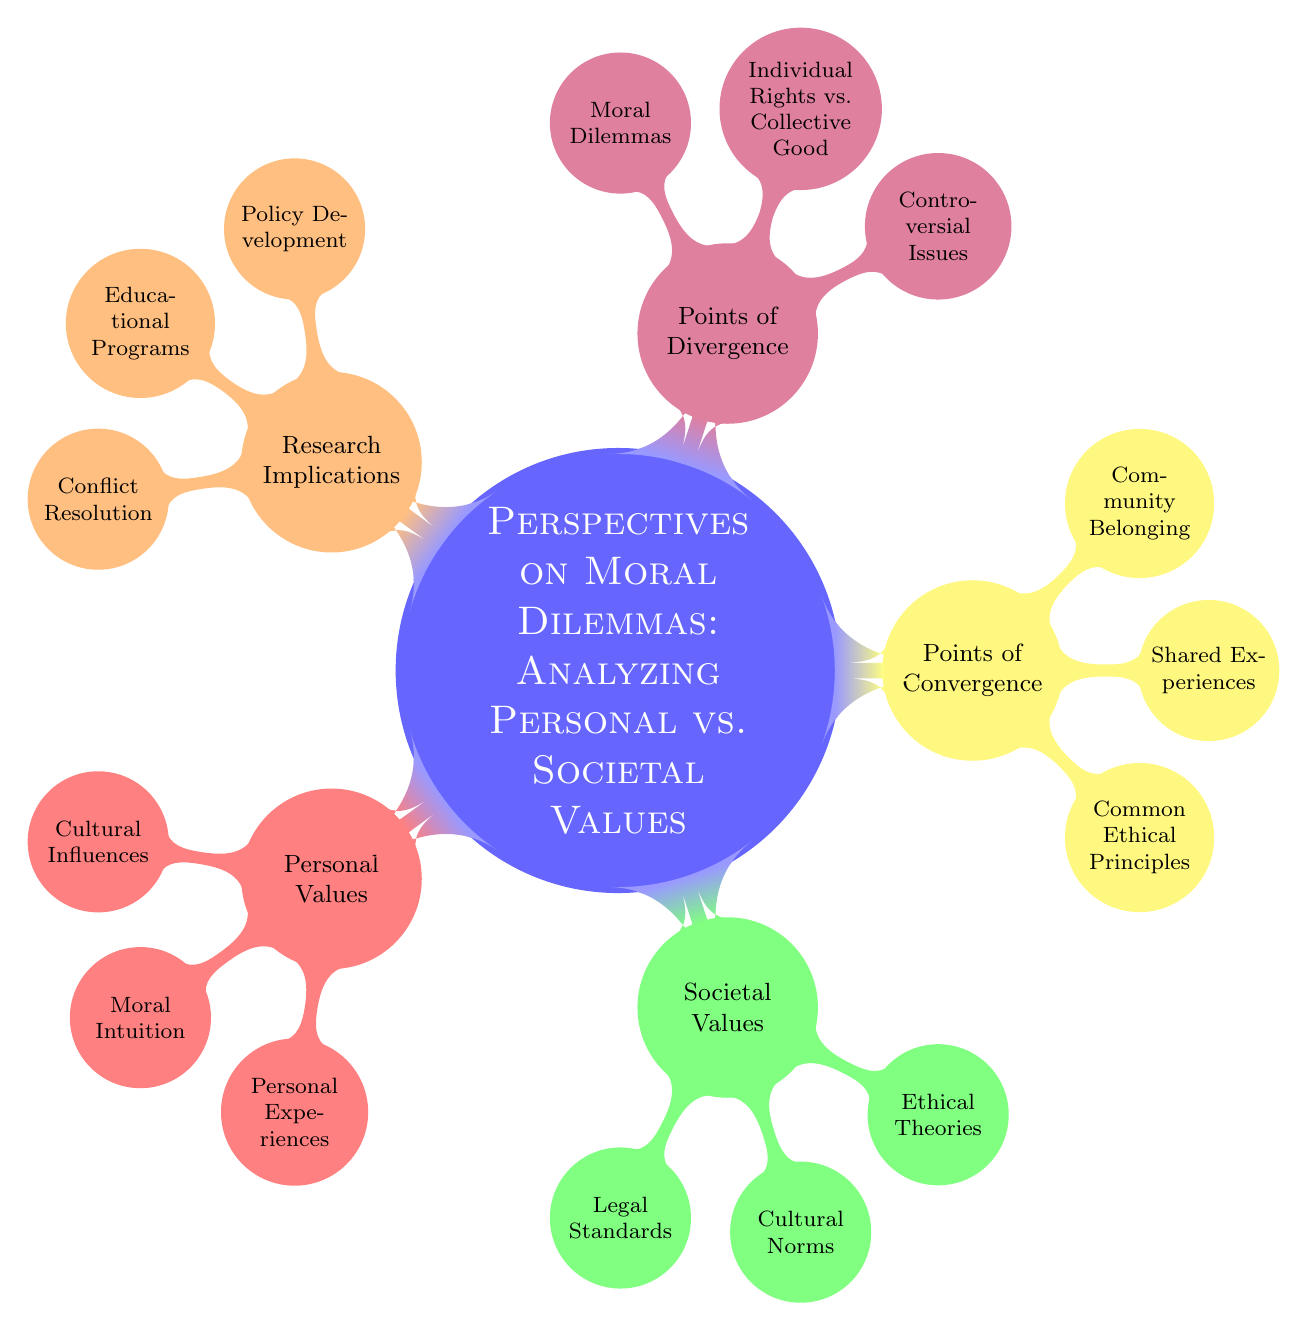What is the central node of the diagram? The central node is explicitly labeled as "Perspectives on Moral Dilemmas: Analyzing Personal vs. Societal Values," signifying the main theme of the mind map.
Answer: Perspectives on Moral Dilemmas: Analyzing Personal vs. Societal Values How many child nodes does "Personal Values" have? The "Personal Values" node has three child nodes listed underneath it: "Cultural Influences," "Moral Intuition," and "Personal Experiences," indicating the specific aspects of personal values.
Answer: 3 What color represents "Societal Values"? The "Societal Values" node is marked with the color green, as visually indicated in the mind map.
Answer: Green What are the "Points of Convergence"? The "Points of Convergence" section is defined as areas where personal and societal values overlap or align, facilitating a better understanding of ethical principles among individuals and society.
Answer: Areas where personal and societal values overlap or align Which node includes "Controversial Issues"? "Controversial Issues" is found under the "Points of Divergence" node indicating that it is a specific area where personal and societal values conflict.
Answer: Points of Divergence Identify one example of "Common Ethical Principles". Under the "Points of Convergence" node, "Common Ethical Principles" is provided as an example; one of its foundational aspects is justice, which encompasses fairness and equality in moral reasoning.
Answer: Justice How do "Personal Values" and "Societal Values" differ? "Personal Values" are individually held beliefs while "Societal Values" are collective norms and standards within a society, demonstrating the distinction between individual moral conviction and societal expectations.
Answer: They differ in that personal values are individual beliefs and societal values are collective norms What does "Research Implications" imply regarding moral dilemmas? "Research Implications" connects the understanding of personal and societal values to practical applications such as "Policy Development," which suggests a direct relationship between moral reasoning and the enactment of laws and policies addressing moral dilemmas.
Answer: Insights for research from understanding personal vs. societal values 